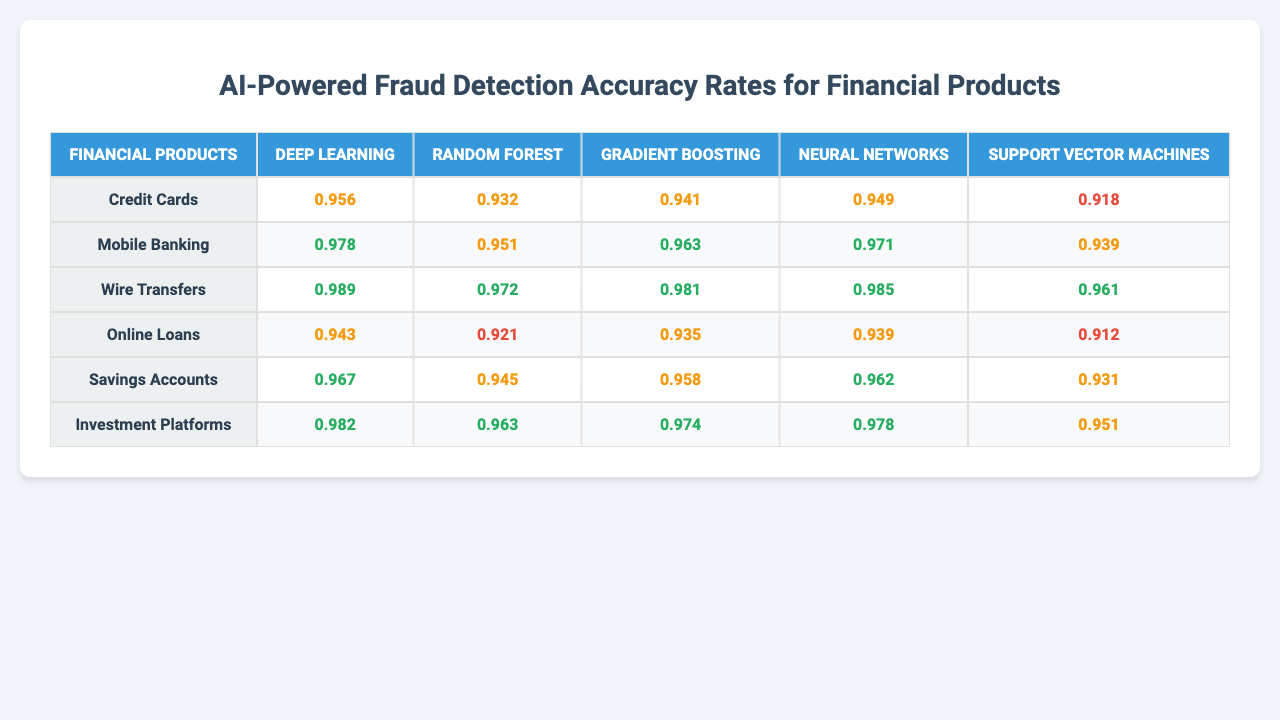What is the highest accuracy rate for "Wire Transfers"? The highest accuracy rate listed under "Wire Transfers" is from the Deep Learning model, which has an accuracy rate of 0.989.
Answer: 0.989 Which AI model has the lowest accuracy rate for "Online Loans"? Among the AI models listed for "Online Loans," the Support Vector Machines model has the lowest accuracy rate of 0.912.
Answer: 0.912 What is the average accuracy rate of "Saving Accounts" across all AI models? The accuracy rates for Savings Accounts are 0.967, 0.945, 0.958, 0.962, and 0.931. The sum is 4.963, and since there are 5 models, the average is 4.963 / 5 = 0.993.
Answer: 0.993 Is the Random Forest model more accurate than the Neural Networks model for "Investment Platforms"? For "Investment Platforms," the accuracy for Random Forest is 0.963 and for Neural Networks it is 0.978. Since 0.963 is less than 0.978, Random Forest is not more accurate.
Answer: No Which product has the highest overall accuracy rate across all AI models? By inspecting the accuracy rates, "Wire Transfers" has the highest values, with the lowest at 0.961 and the maximum at 0.989. Therefore, it has the highest overall accuracy when compared to others.
Answer: Wire Transfers What is the difference in accuracy rates between the "Deep Learning" model for "Mobile Banking" and "Online Loans"? The accuracy for Mobile Banking with Deep Learning is 0.978, and for Online Loans, it is 0.943. The difference is 0.978 - 0.943 = 0.035.
Answer: 0.035 Which financial product consistently has high accuracy rates across all models? "Wire Transfers" shows consistent high accuracy rates, with all model accuracy rates exceeding 0.961. Hence, it consistently ranks high across the board.
Answer: Wire Transfers Are there any models with accuracy rates below 0.93 for "Credit Cards"? The model with the lowest accuracy for "Credit Cards" is Support Vector Machines at 0.918, which is below 0.93. Hence, at least one model does fall below that threshold.
Answer: Yes What is the second highest accuracy rate for "Savings Accounts"? In "Savings Accounts," the accuracy rates are 0.967, 0.945, 0.958, 0.962, and 0.931. When sorted, the second highest is 0.962.
Answer: 0.962 Which AI model has the highest accuracy across all financial products? By evaluating all the AI models' maximum accuracies, Deep Learning has the highest accuracy rate of 0.989 for "Wire Transfers." Thus, it holds the highest accuracy overall across all financial products.
Answer: Deep Learning 